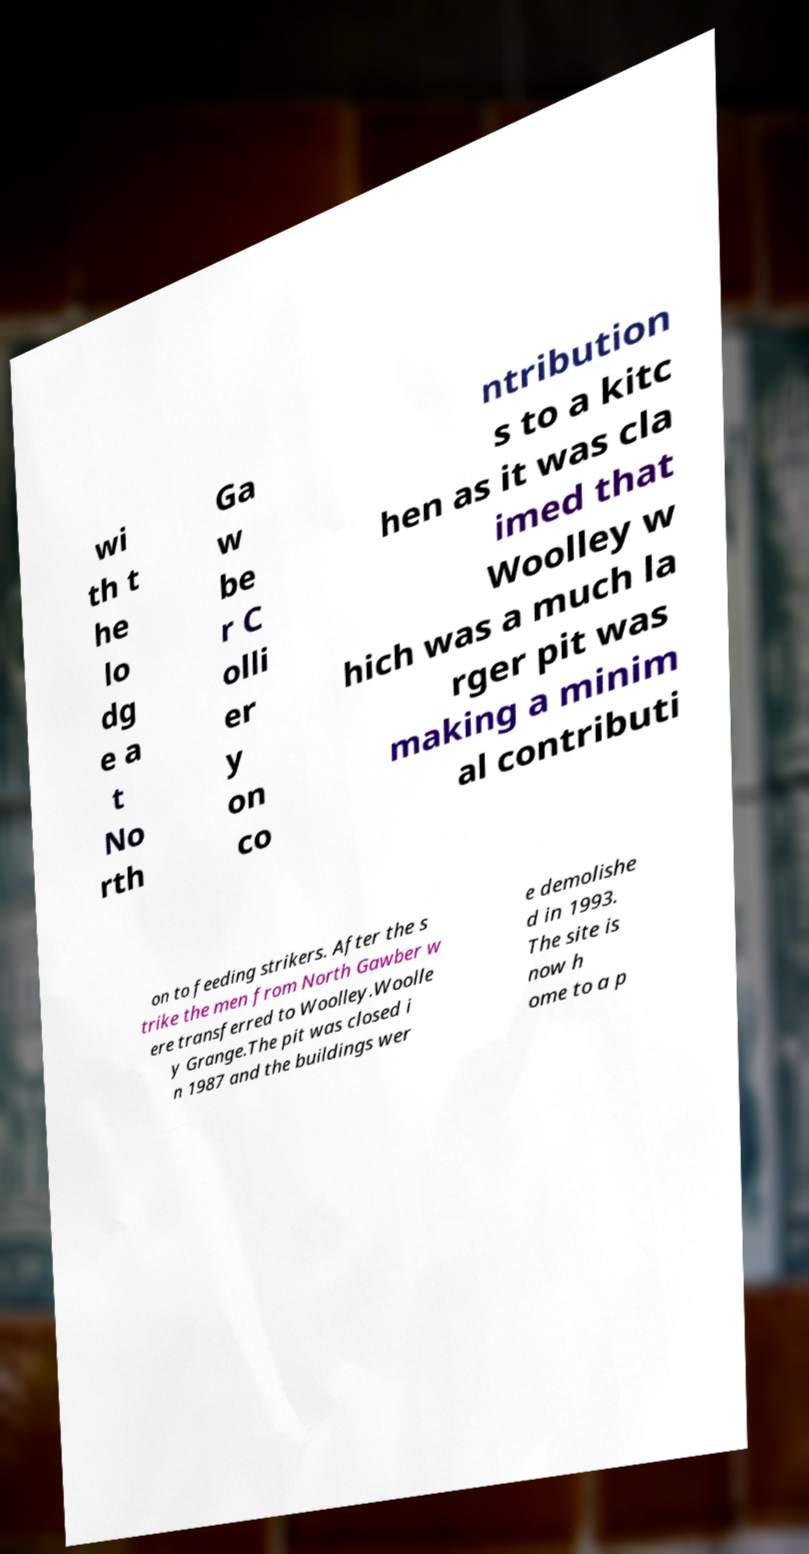What messages or text are displayed in this image? I need them in a readable, typed format. wi th t he lo dg e a t No rth Ga w be r C olli er y on co ntribution s to a kitc hen as it was cla imed that Woolley w hich was a much la rger pit was making a minim al contributi on to feeding strikers. After the s trike the men from North Gawber w ere transferred to Woolley.Woolle y Grange.The pit was closed i n 1987 and the buildings wer e demolishe d in 1993. The site is now h ome to a p 